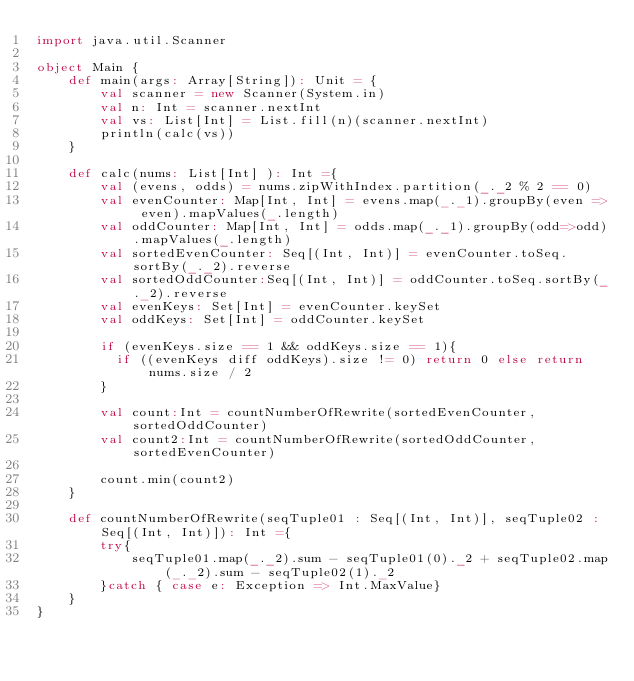Convert code to text. <code><loc_0><loc_0><loc_500><loc_500><_Scala_>import java.util.Scanner

object Main {
    def main(args: Array[String]): Unit = {
        val scanner = new Scanner(System.in)
        val n: Int = scanner.nextInt
        val vs: List[Int] = List.fill(n)(scanner.nextInt)
        println(calc(vs))
    }

    def calc(nums: List[Int] ): Int ={
        val (evens, odds) = nums.zipWithIndex.partition(_._2 % 2 == 0)
        val evenCounter: Map[Int, Int] = evens.map(_._1).groupBy(even => even).mapValues(_.length)
        val oddCounter: Map[Int, Int] = odds.map(_._1).groupBy(odd=>odd).mapValues(_.length)
        val sortedEvenCounter: Seq[(Int, Int)] = evenCounter.toSeq.sortBy(_._2).reverse
        val sortedOddCounter:Seq[(Int, Int)] = oddCounter.toSeq.sortBy(_._2).reverse
        val evenKeys: Set[Int] = evenCounter.keySet
        val oddKeys: Set[Int] = oddCounter.keySet

        if (evenKeys.size == 1 && oddKeys.size == 1){
          if ((evenKeys diff oddKeys).size != 0) return 0 else return nums.size / 2
        }

        val count:Int = countNumberOfRewrite(sortedEvenCounter, sortedOddCounter)
        val count2:Int = countNumberOfRewrite(sortedOddCounter, sortedEvenCounter)

        count.min(count2)
    }

    def countNumberOfRewrite(seqTuple01 : Seq[(Int, Int)], seqTuple02 :Seq[(Int, Int)]): Int ={
        try{
            seqTuple01.map(_._2).sum - seqTuple01(0)._2 + seqTuple02.map(_._2).sum - seqTuple02(1)._2
        }catch { case e: Exception => Int.MaxValue}
    }
}</code> 